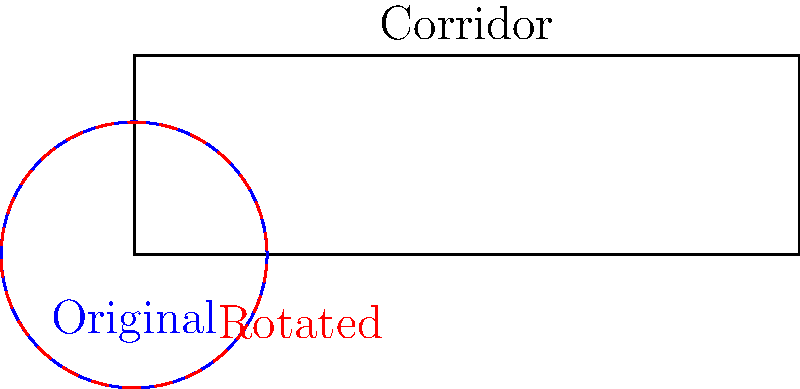A circular piece of medical equipment with a diameter of 2 meters needs to be moved through a hospital corridor that is 3 meters wide. What is the maximum angle (in degrees) that the equipment needs to be rotated to fit through the corridor without touching the walls? To solve this problem, we need to follow these steps:

1. Understand the given information:
   - The equipment is circular with a diameter of 2 meters
   - The corridor is 3 meters wide

2. Visualize the problem:
   - The equipment needs to be rotated to fit diagonally in the corridor

3. Use trigonometry to find the maximum angle:
   - In a right triangle formed by the rotated equipment:
     - The hypotenuse is the diameter of the equipment (2 meters)
     - The opposite side is the width of the corridor (3 meters)

4. Apply the inverse sine function:
   $$\theta = \arcsin(\frac{\text{opposite}}{\text{hypotenuse}})$$
   $$\theta = \arcsin(\frac{3}{2})$$

5. Calculate the result:
   $$\theta \approx 41.81\text{ degrees}$$

6. The equipment needs to be rotated by the complement of this angle:
   $$90^\circ - 41.81^\circ \approx 48.19\text{ degrees}$$

Therefore, the maximum angle the equipment needs to be rotated is approximately 48.19 degrees.
Answer: 48.19 degrees 